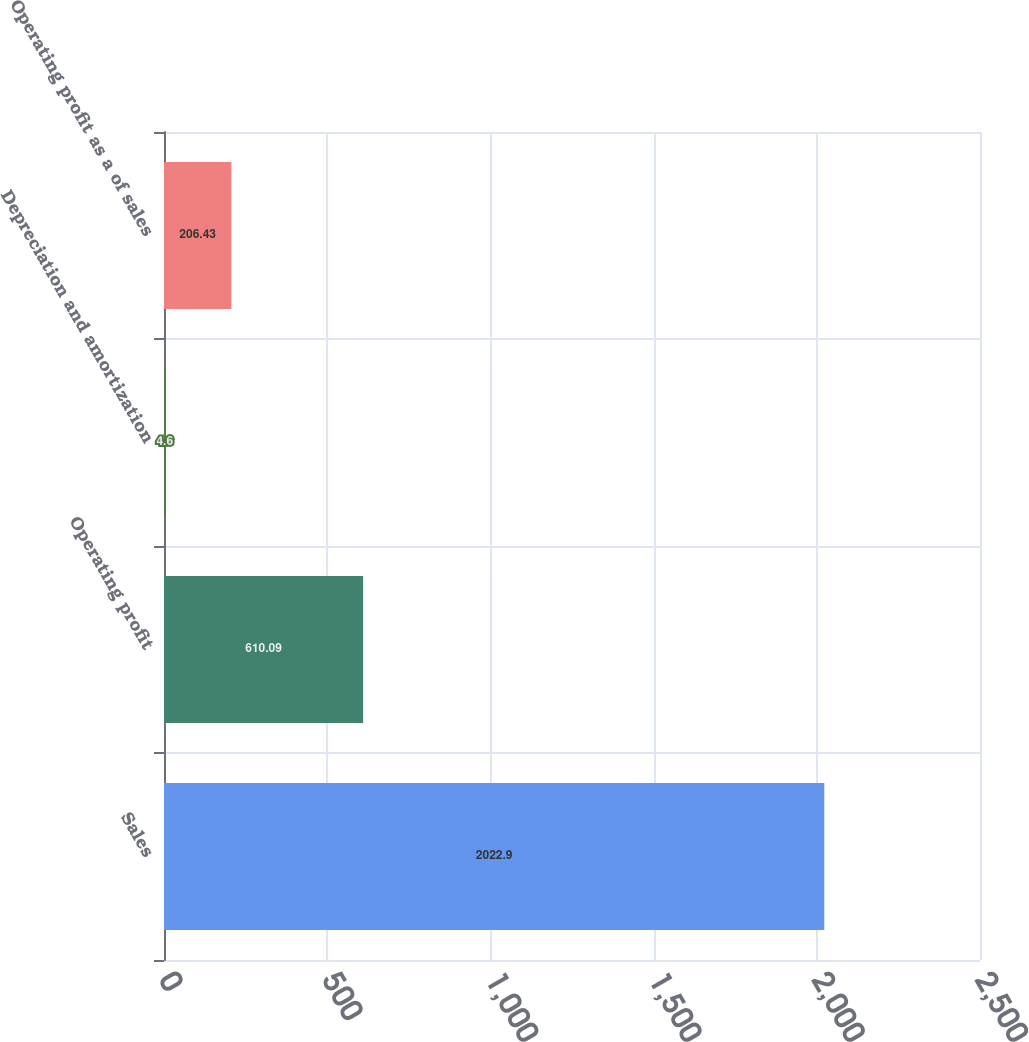Convert chart to OTSL. <chart><loc_0><loc_0><loc_500><loc_500><bar_chart><fcel>Sales<fcel>Operating profit<fcel>Depreciation and amortization<fcel>Operating profit as a of sales<nl><fcel>2022.9<fcel>610.09<fcel>4.6<fcel>206.43<nl></chart> 